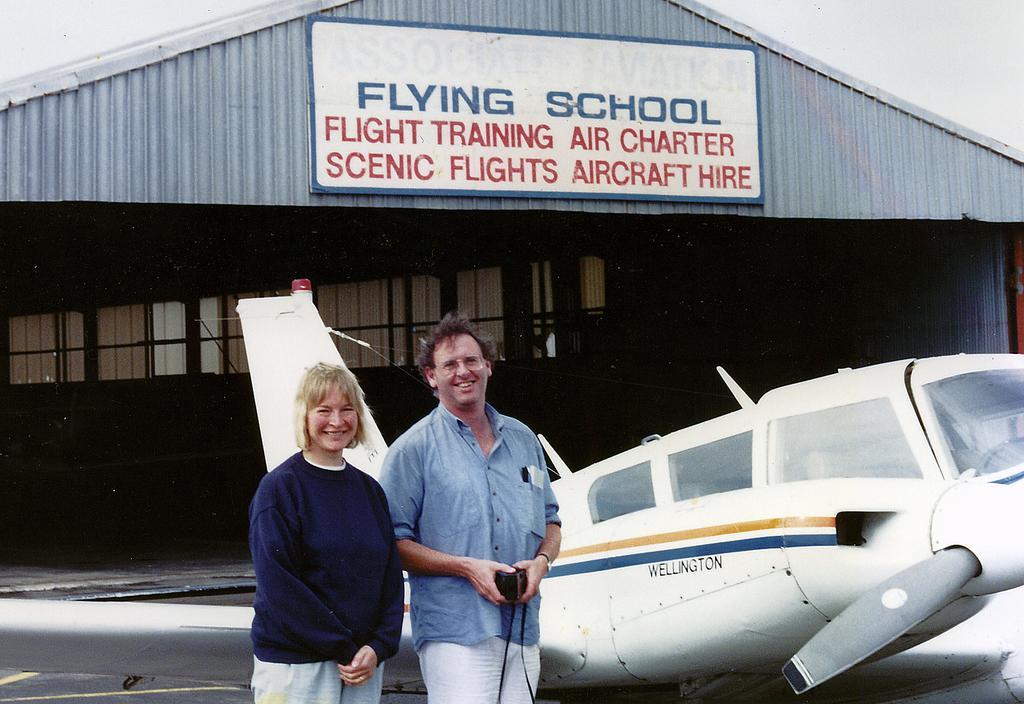How would you summarize this image in a sentence or two? In this image we can see two persons standing near aircraft. And in the background, we can see the shelter. And we can see some written text on it. And we can see the sky. 